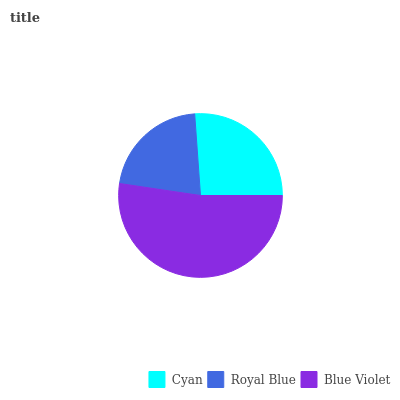Is Royal Blue the minimum?
Answer yes or no. Yes. Is Blue Violet the maximum?
Answer yes or no. Yes. Is Blue Violet the minimum?
Answer yes or no. No. Is Royal Blue the maximum?
Answer yes or no. No. Is Blue Violet greater than Royal Blue?
Answer yes or no. Yes. Is Royal Blue less than Blue Violet?
Answer yes or no. Yes. Is Royal Blue greater than Blue Violet?
Answer yes or no. No. Is Blue Violet less than Royal Blue?
Answer yes or no. No. Is Cyan the high median?
Answer yes or no. Yes. Is Cyan the low median?
Answer yes or no. Yes. Is Royal Blue the high median?
Answer yes or no. No. Is Royal Blue the low median?
Answer yes or no. No. 